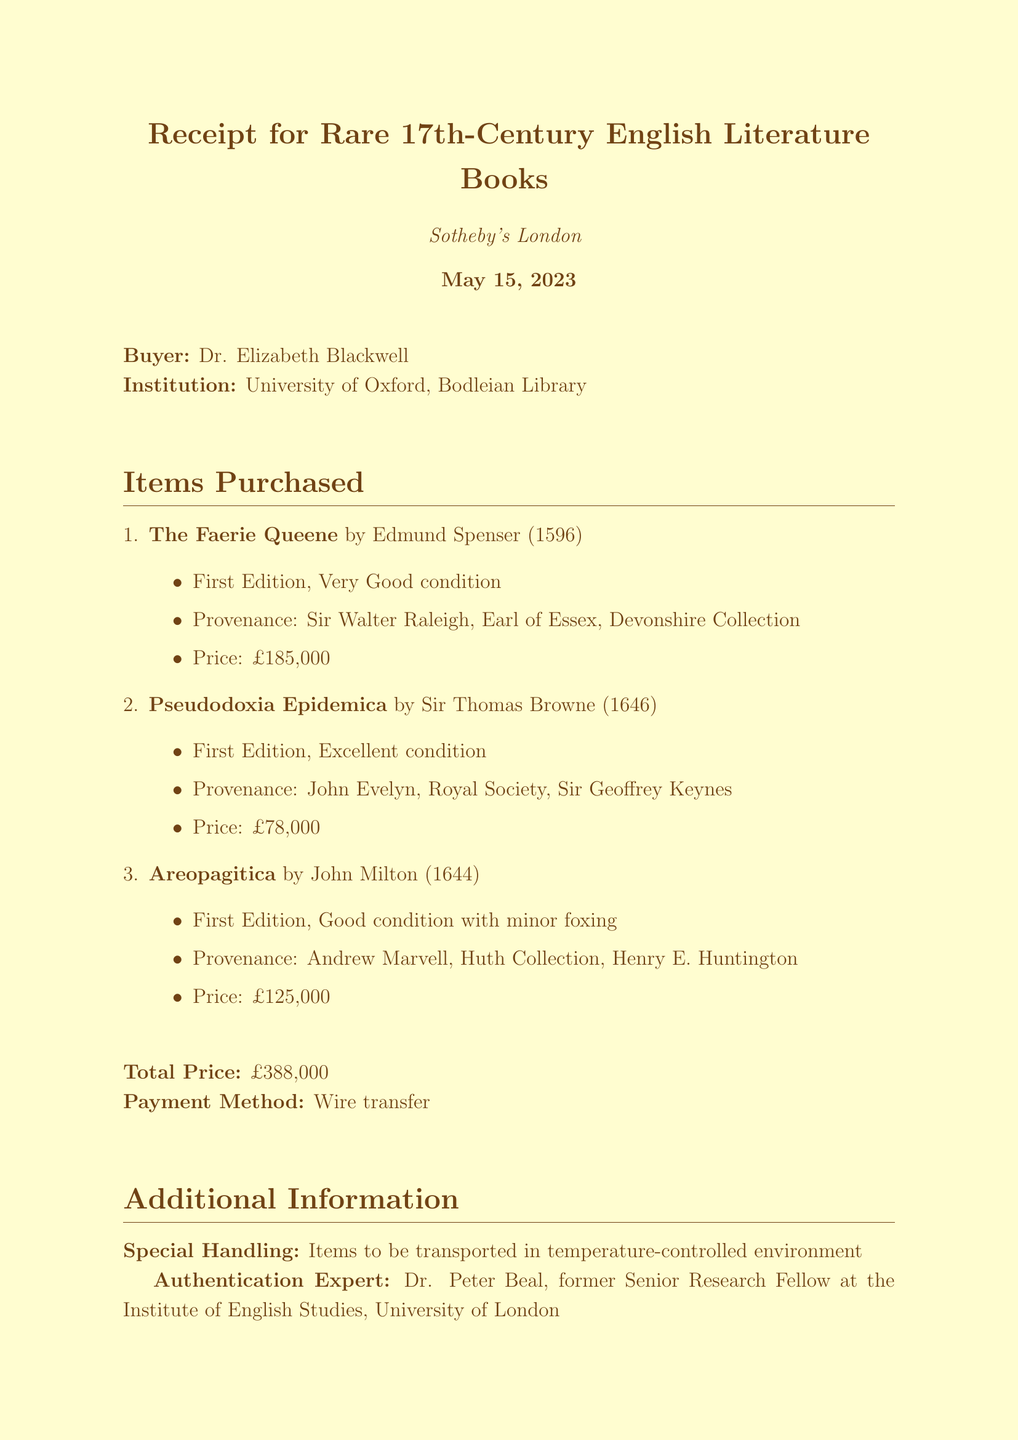What is the auction house? The auction house is the organization where the auction took place, which is specified in the document.
Answer: Sotheby's London Who bought the books? The buyer's name is stated in the receipt, detailing who made the purchase.
Answer: Dr. Elizabeth Blackwell What was the total price? The total price can be found as a sum of all individual prices listed for the purchased items in the document.
Answer: £388,000 What is the condition of "Areopagitica"? The condition of the book is defined in the document as part of the item descriptions.
Answer: Good, with minor foxing Who was the authentication expert? The document lists an expert responsible for authenticating the purchases, providing their name and title.
Answer: Dr. Peter Beal What year was "Pseudodoxia Epidemica" published? The publication year for this book is part of the item's information provided in the document.
Answer: 1646 What special handling instructions were given? Specific handling instructions for the items during transport are included in the document.
Answer: Items to be transported in temperature-controlled environment Which collection was "Areopagitica" part of until 1911? The document mentions relevant historical collections associated with the books, helping to trace their provenance.
Answer: Huth Collection 